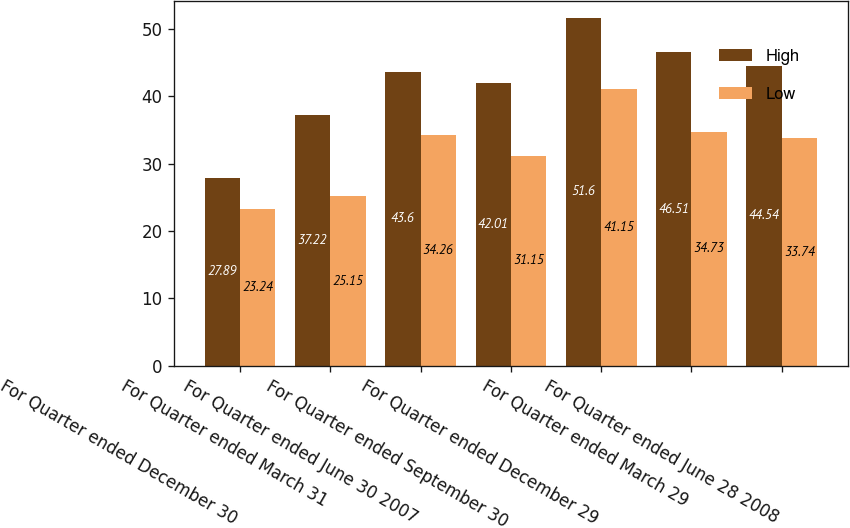<chart> <loc_0><loc_0><loc_500><loc_500><stacked_bar_chart><ecel><fcel>For Quarter ended December 30<fcel>For Quarter ended March 31<fcel>For Quarter ended June 30 2007<fcel>For Quarter ended September 30<fcel>For Quarter ended December 29<fcel>For Quarter ended March 29<fcel>For Quarter ended June 28 2008<nl><fcel>High<fcel>27.89<fcel>37.22<fcel>43.6<fcel>42.01<fcel>51.6<fcel>46.51<fcel>44.54<nl><fcel>Low<fcel>23.24<fcel>25.15<fcel>34.26<fcel>31.15<fcel>41.15<fcel>34.73<fcel>33.74<nl></chart> 